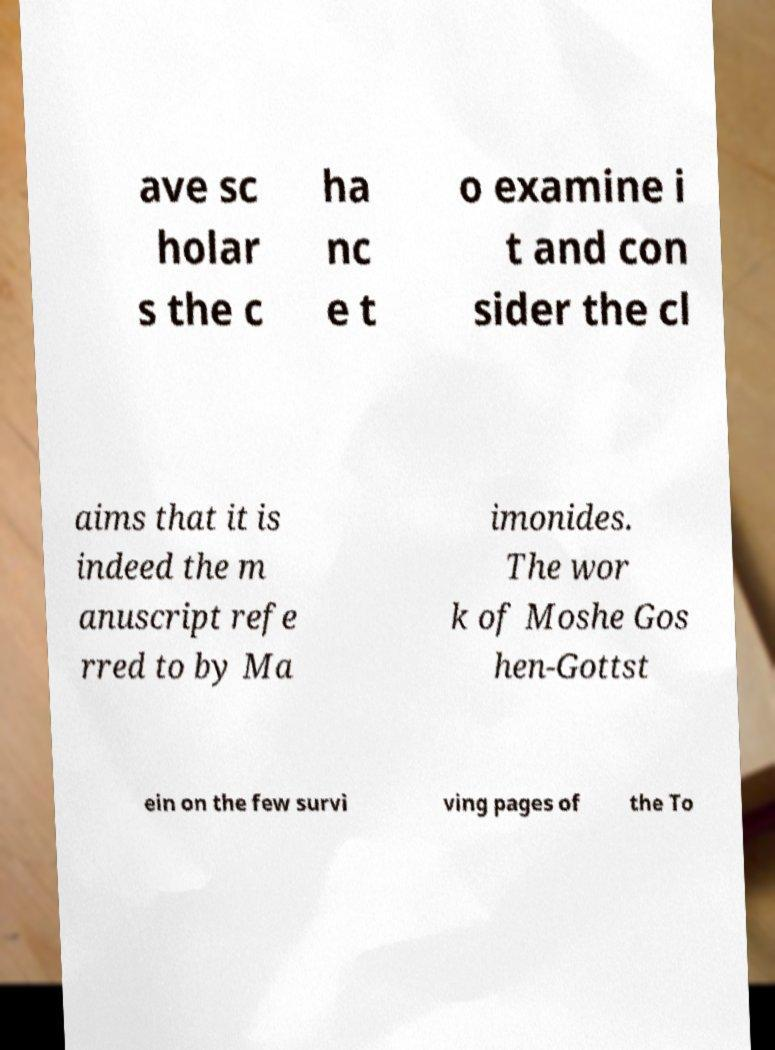For documentation purposes, I need the text within this image transcribed. Could you provide that? ave sc holar s the c ha nc e t o examine i t and con sider the cl aims that it is indeed the m anuscript refe rred to by Ma imonides. The wor k of Moshe Gos hen-Gottst ein on the few survi ving pages of the To 